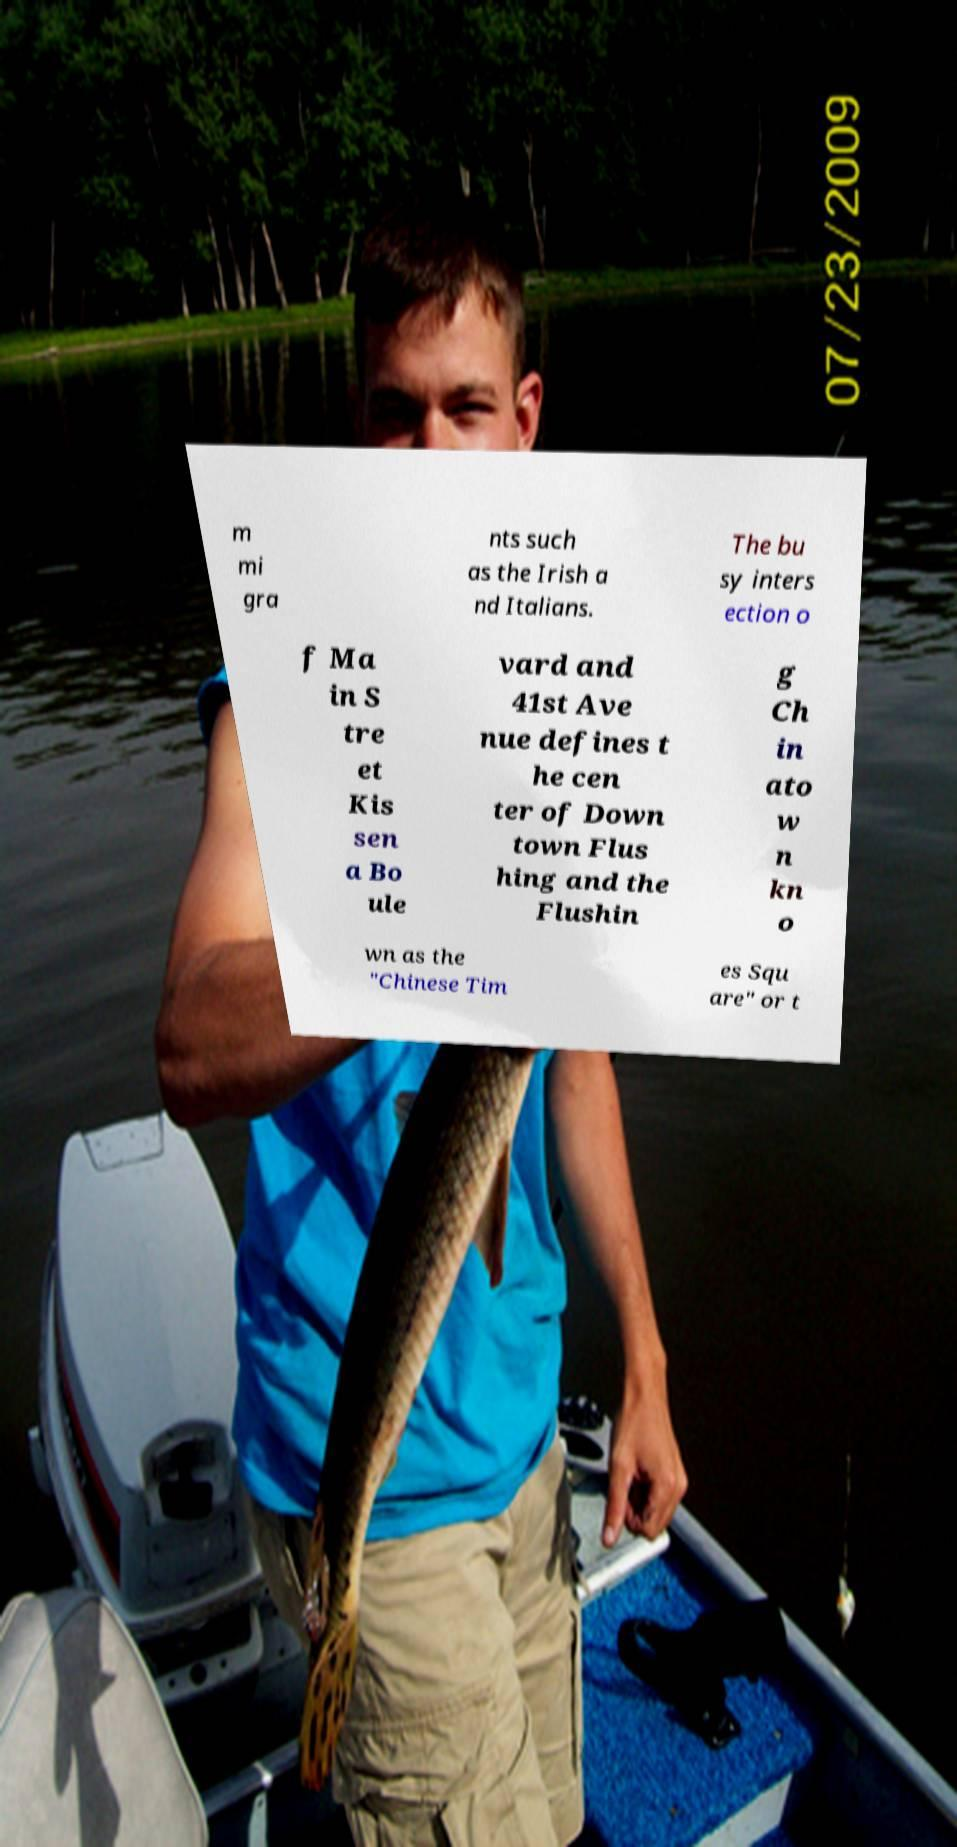There's text embedded in this image that I need extracted. Can you transcribe it verbatim? m mi gra nts such as the Irish a nd Italians. The bu sy inters ection o f Ma in S tre et Kis sen a Bo ule vard and 41st Ave nue defines t he cen ter of Down town Flus hing and the Flushin g Ch in ato w n kn o wn as the "Chinese Tim es Squ are" or t 